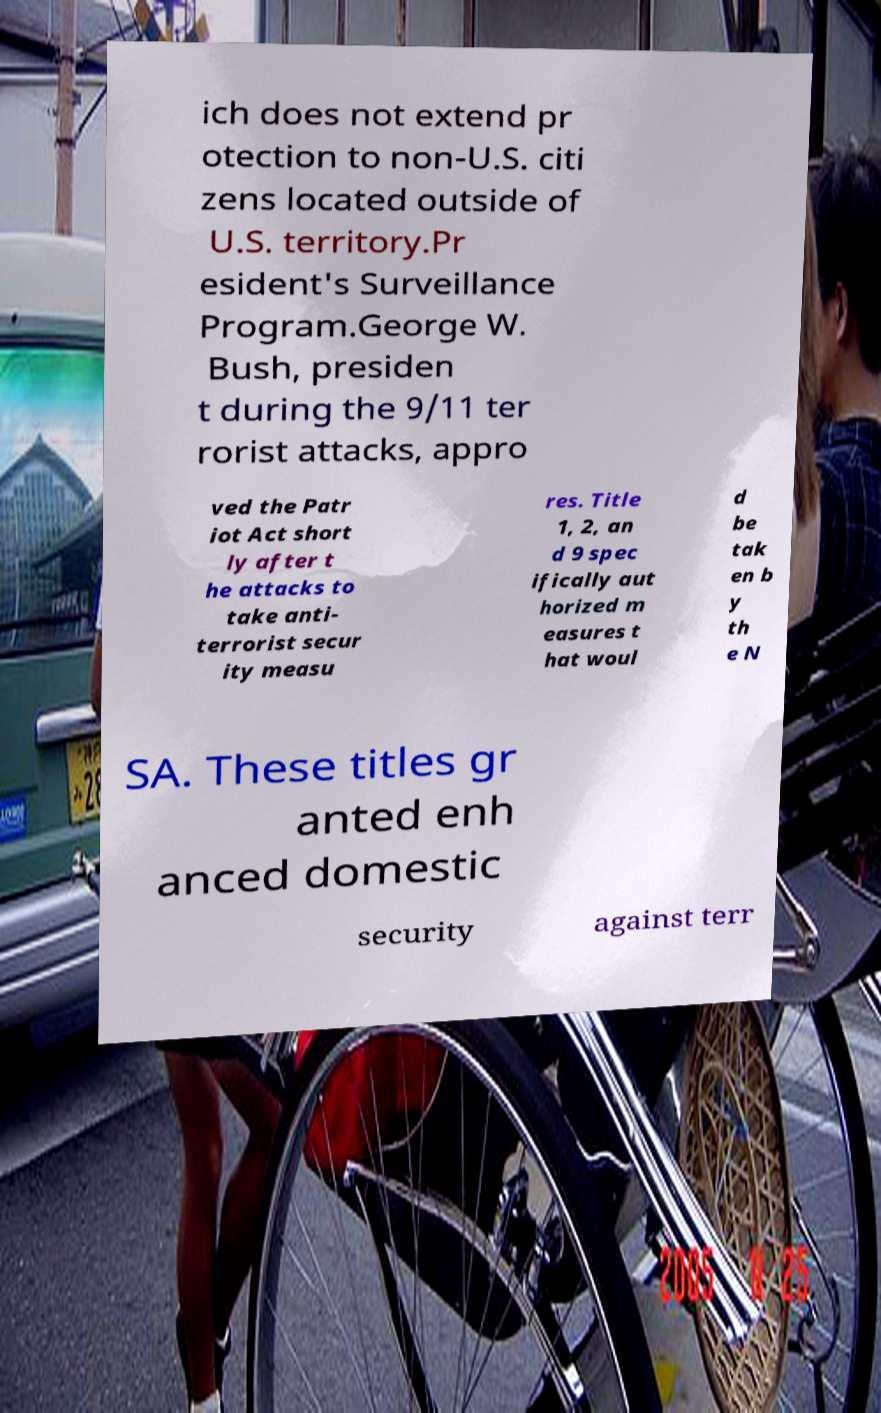Please identify and transcribe the text found in this image. ich does not extend pr otection to non-U.S. citi zens located outside of U.S. territory.Pr esident's Surveillance Program.George W. Bush, presiden t during the 9/11 ter rorist attacks, appro ved the Patr iot Act short ly after t he attacks to take anti- terrorist secur ity measu res. Title 1, 2, an d 9 spec ifically aut horized m easures t hat woul d be tak en b y th e N SA. These titles gr anted enh anced domestic security against terr 